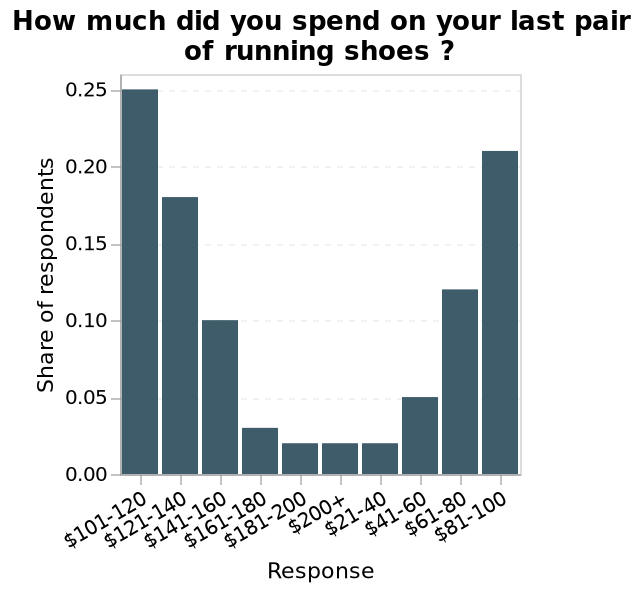<image>
What is plotted on the x-axis of the bar diagram?  The x-axis of the bar diagram displays the responses with a categorical scale ranging from $101-120 to $81-100. What is the highest amount spent on running shoes by a respondent? The highest amount spent on running shoes by a respondent is over $200. What is the lowest amount spent on running shoes by a respondent? The lowest amount spent on running shoes by a respondent is under $60. What percentage of respondents spent over $200 on their last pair of running shoes?  Less than 0.05% of respondents spent over $200 on their last pair of running shoes. How much did the majority of people spend on their last pair of running shoes?  The majority of people spent under $120 on their last pair of running shoes. 